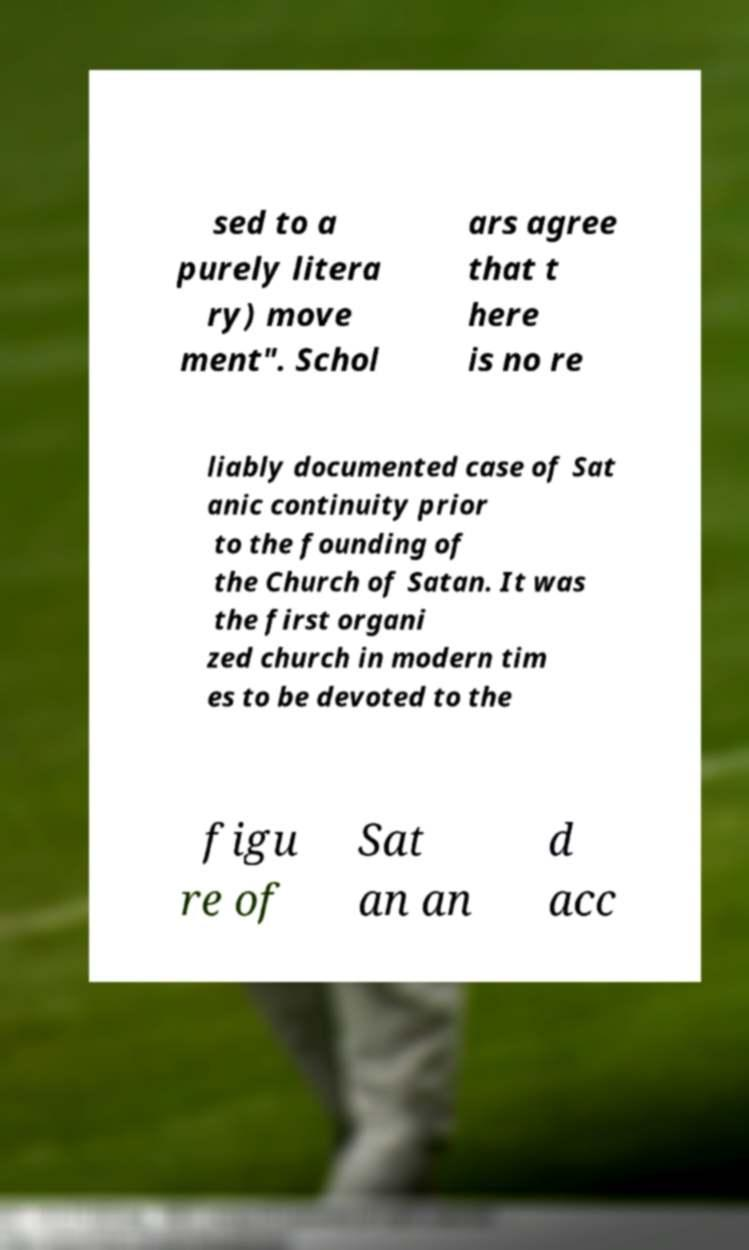There's text embedded in this image that I need extracted. Can you transcribe it verbatim? sed to a purely litera ry) move ment". Schol ars agree that t here is no re liably documented case of Sat anic continuity prior to the founding of the Church of Satan. It was the first organi zed church in modern tim es to be devoted to the figu re of Sat an an d acc 